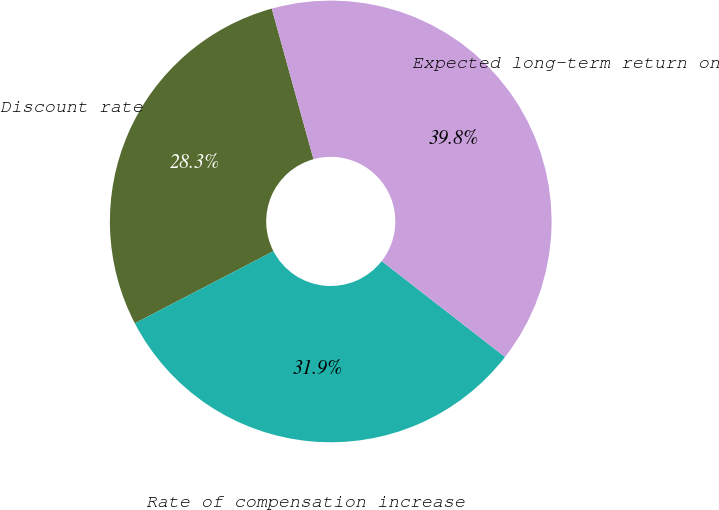Convert chart. <chart><loc_0><loc_0><loc_500><loc_500><pie_chart><fcel>Discount rate<fcel>Rate of compensation increase<fcel>Expected long-term return on<nl><fcel>28.33%<fcel>31.85%<fcel>39.82%<nl></chart> 